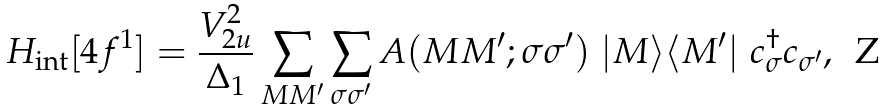<formula> <loc_0><loc_0><loc_500><loc_500>H _ { \text {int} } [ 4 f ^ { 1 } ] = \frac { V _ { 2 u } ^ { 2 } } { \Delta _ { 1 } } \sum _ { M M ^ { \prime } } \sum _ { \sigma \sigma ^ { \prime } } A ( M M ^ { \prime } ; \sigma \sigma ^ { \prime } ) \ | M \rangle \langle M ^ { \prime } | \ c ^ { \dag } _ { \sigma } c _ { \sigma ^ { \prime } } ,</formula> 